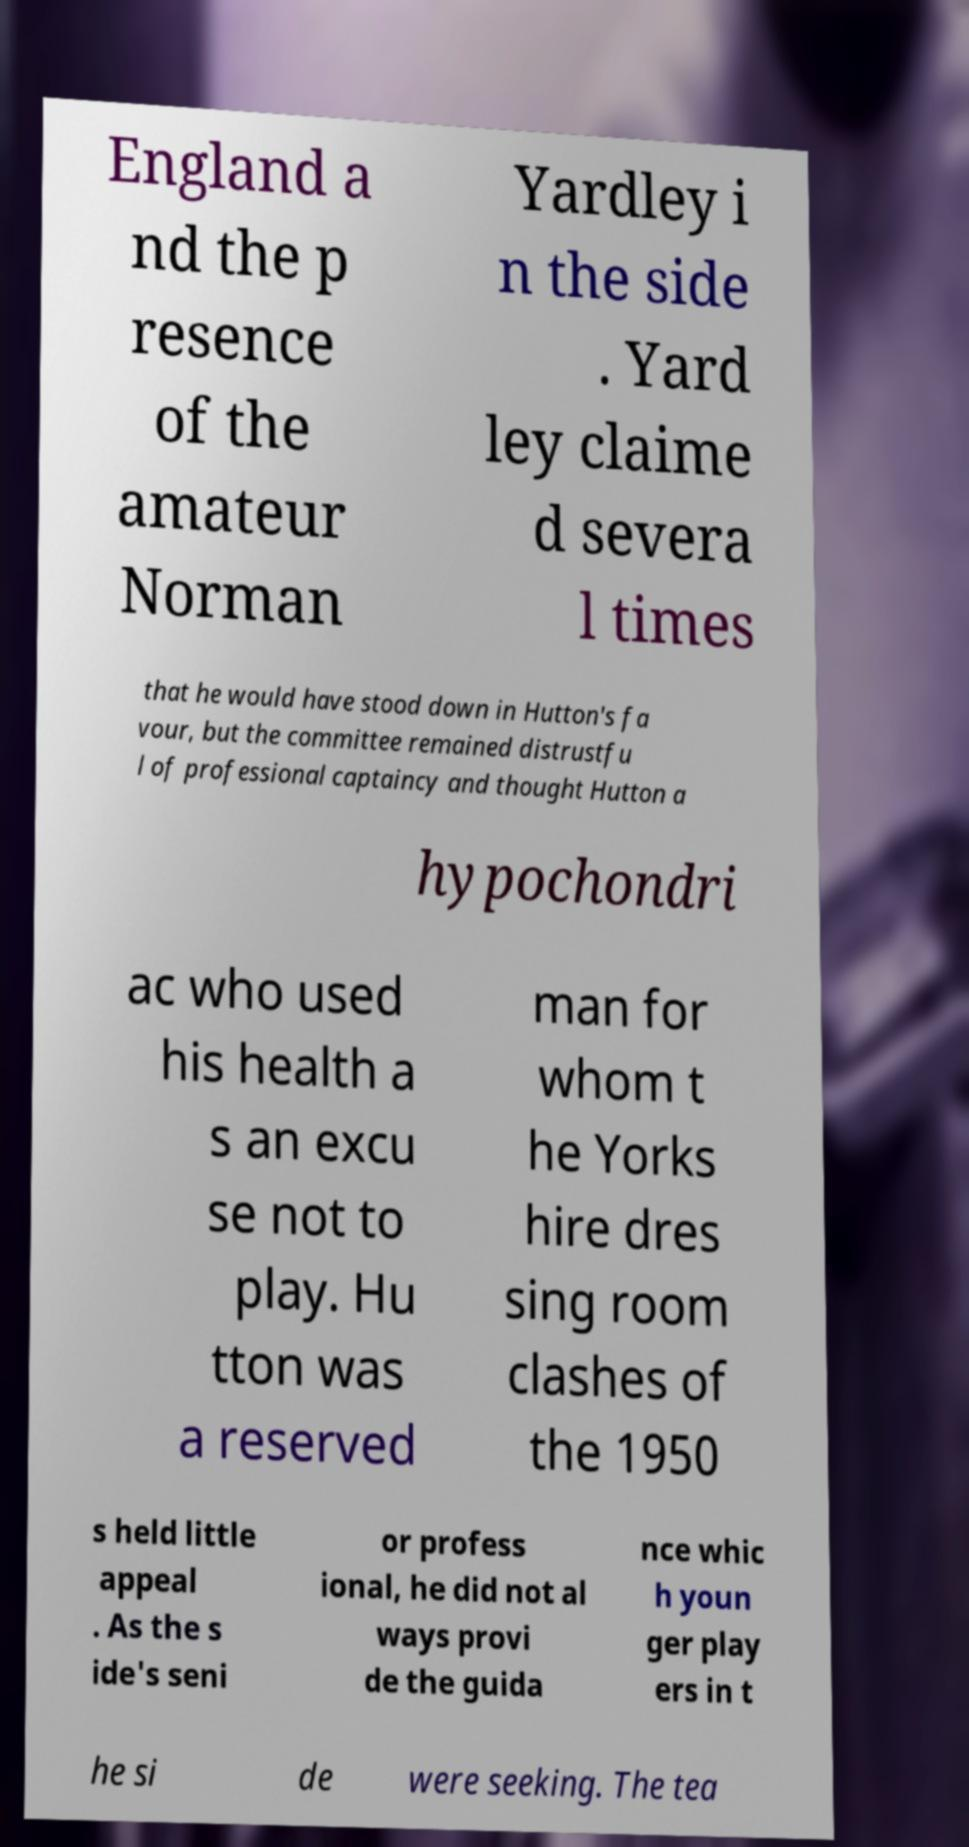Can you accurately transcribe the text from the provided image for me? England a nd the p resence of the amateur Norman Yardley i n the side . Yard ley claime d severa l times that he would have stood down in Hutton's fa vour, but the committee remained distrustfu l of professional captaincy and thought Hutton a hypochondri ac who used his health a s an excu se not to play. Hu tton was a reserved man for whom t he Yorks hire dres sing room clashes of the 1950 s held little appeal . As the s ide's seni or profess ional, he did not al ways provi de the guida nce whic h youn ger play ers in t he si de were seeking. The tea 